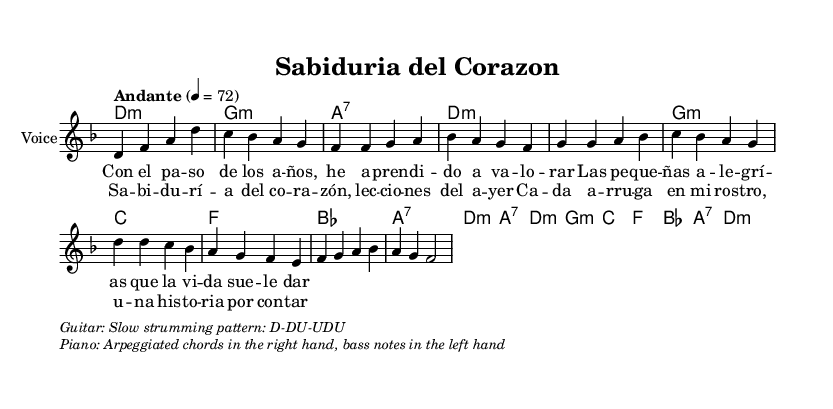What is the key signature of this music? The key signature is D minor, which has one flat (B flat). D minor is represented by the "a flat" symbol located after the clef at the beginning of the staff.
Answer: D minor What is the time signature of this piece? The time signature shown in the sheet music is 4/4, indicated by the "4/4" notation at the beginning of the score. This means there are four beats in each measure.
Answer: 4/4 What is the tempo marking for this music? The tempo marking is "Andante," which is indicated in the score and suggests a moderate walking pace. It also includes the metronome marking of 72 beats per minute.
Answer: Andante How many measures are in the chorus section? By counting the measures in the chorus lyrics and melody, we see there are a total of four measures. Each measure is separated by the bar lines in the score.
Answer: Four What is the predominant chord type used throughout the song? The predominant chord type is minor, as seen in the use of D minor, G minor, and A7 chords, which are common in traditional boleros reflecting on focused emotional experiences.
Answer: Minor What is the main theme of this bolero as reflected in the lyrics? The lyrics express the theme of "wisdom of the heart," which reflects on life's experiences and the lessons learned from them, inherent in the narrative style typical of traditional boleros.
Answer: Wisdom of the heart Can you find the first note of the melody? The first note of the melody is D, indicated at the beginning of the score, which begins with the "d4" notation. This denotes the first pitch of the piece.
Answer: D 